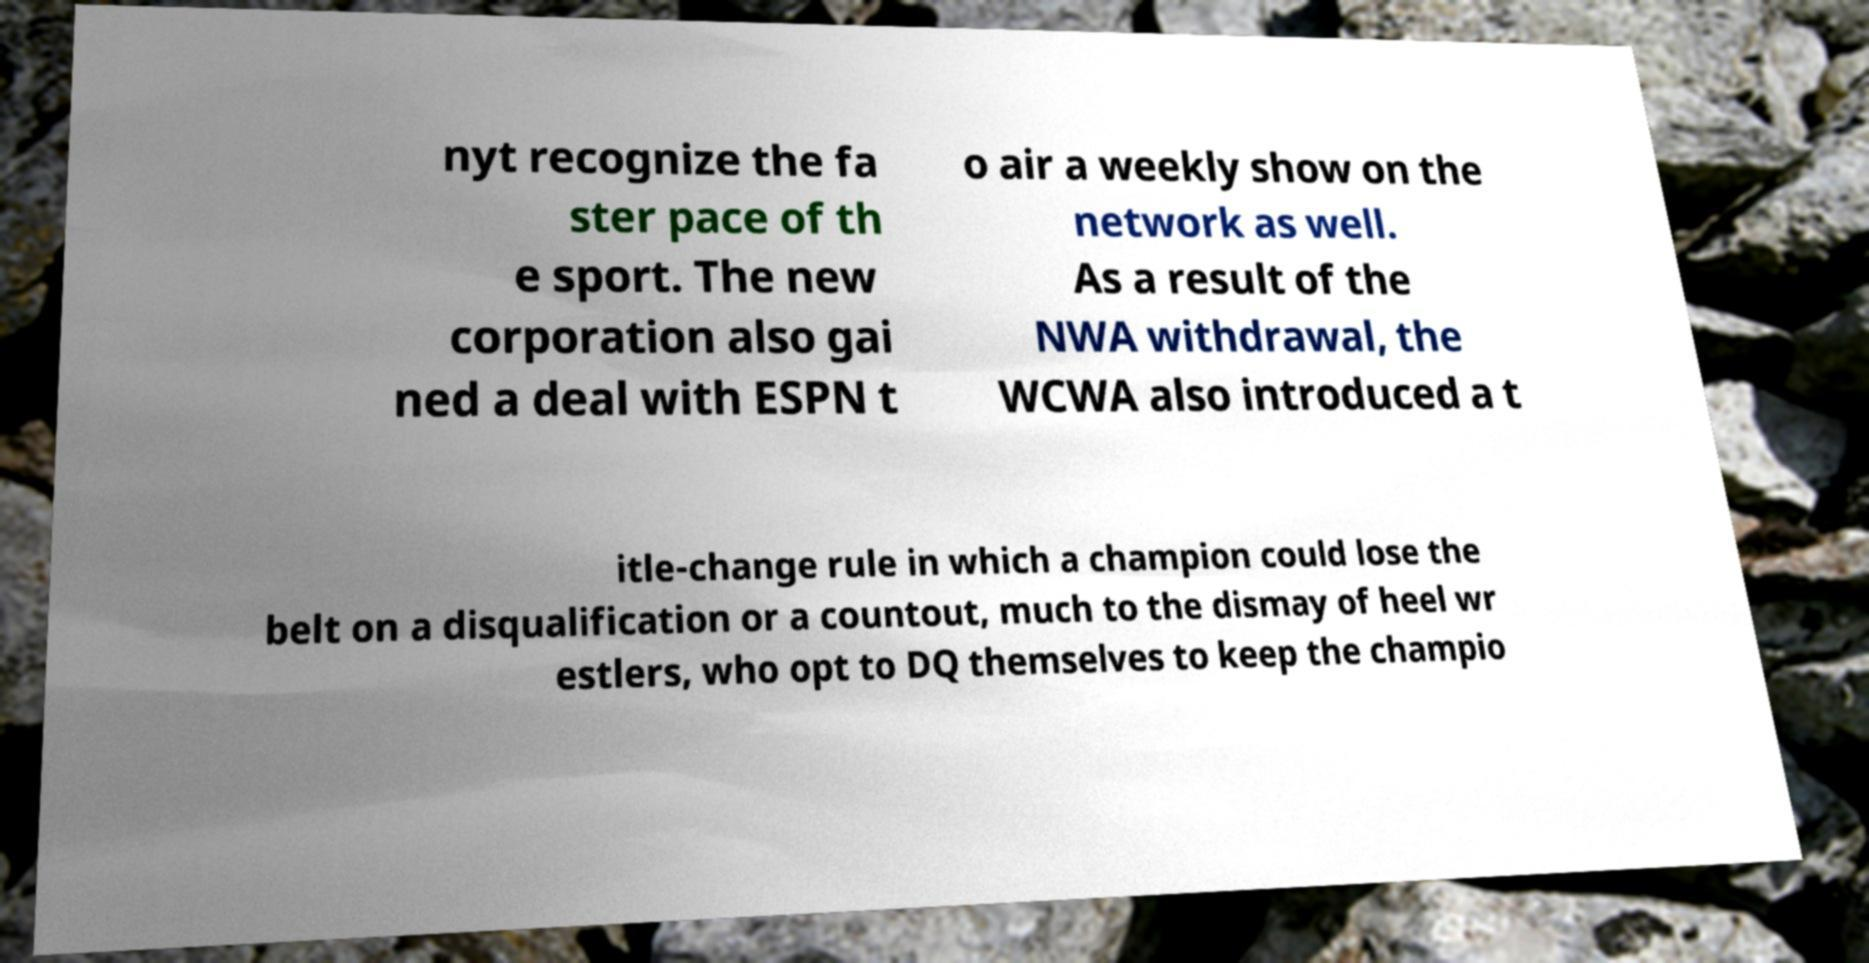Could you extract and type out the text from this image? nyt recognize the fa ster pace of th e sport. The new corporation also gai ned a deal with ESPN t o air a weekly show on the network as well. As a result of the NWA withdrawal, the WCWA also introduced a t itle-change rule in which a champion could lose the belt on a disqualification or a countout, much to the dismay of heel wr estlers, who opt to DQ themselves to keep the champio 